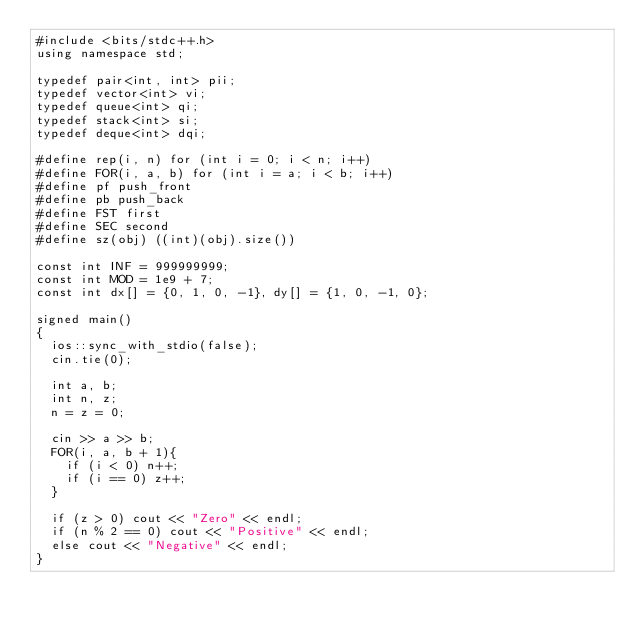<code> <loc_0><loc_0><loc_500><loc_500><_C++_>#include <bits/stdc++.h>
using namespace std;

typedef pair<int, int> pii;
typedef vector<int> vi;
typedef queue<int> qi;
typedef stack<int> si;
typedef deque<int> dqi;

#define rep(i, n) for (int i = 0; i < n; i++)
#define FOR(i, a, b) for (int i = a; i < b; i++)
#define pf push_front
#define pb push_back
#define FST first
#define SEC second
#define sz(obj) ((int)(obj).size())

const int INF = 999999999;
const int MOD = 1e9 + 7;
const int dx[] = {0, 1, 0, -1}, dy[] = {1, 0, -1, 0};

signed main()
{
  ios::sync_with_stdio(false);
  cin.tie(0);

  int a, b;
  int n, z;
  n = z = 0;
  
  cin >> a >> b;
  FOR(i, a, b + 1){
    if (i < 0) n++;
    if (i == 0) z++;
  }

  if (z > 0) cout << "Zero" << endl;
  if (n % 2 == 0) cout << "Positive" << endl;
  else cout << "Negative" << endl;
}
</code> 